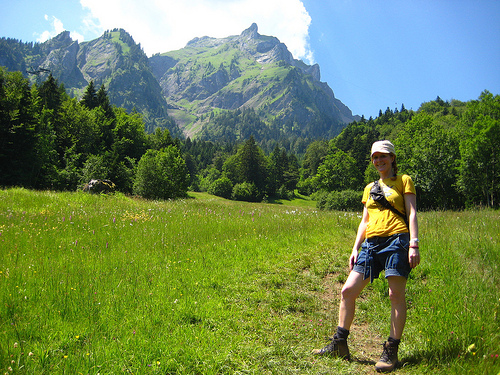<image>
Can you confirm if the mountain is behind the trees? Yes. From this viewpoint, the mountain is positioned behind the trees, with the trees partially or fully occluding the mountain. Where is the women in relation to the grass? Is it behind the grass? No. The women is not behind the grass. From this viewpoint, the women appears to be positioned elsewhere in the scene. Is there a tree on the grass? Yes. Looking at the image, I can see the tree is positioned on top of the grass, with the grass providing support. Where is the hiker in relation to the sky? Is it on the sky? No. The hiker is not positioned on the sky. They may be near each other, but the hiker is not supported by or resting on top of the sky. 